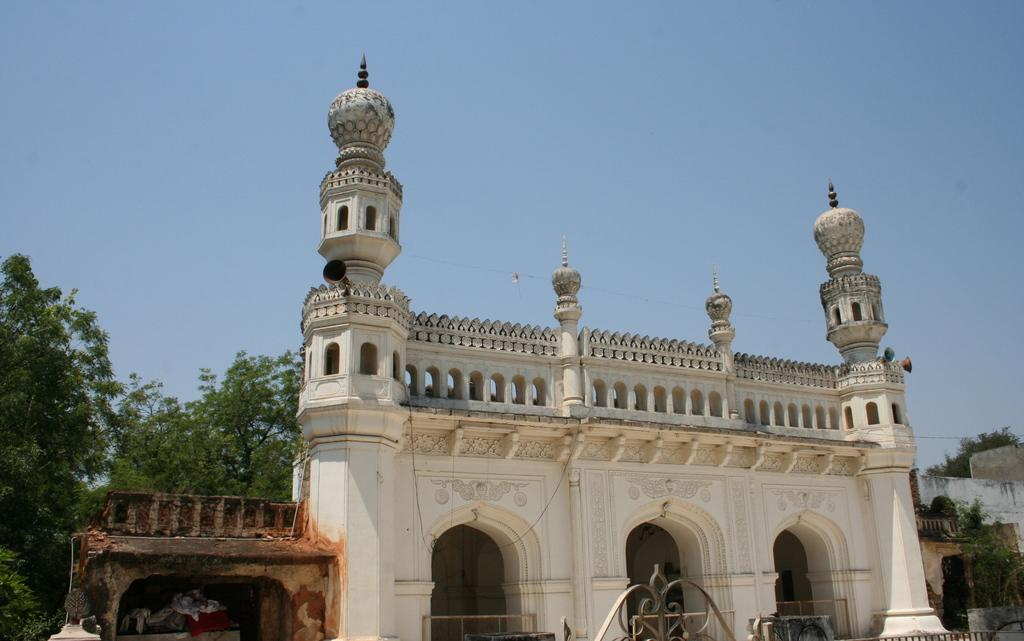What is the main subject of the image? There is a monument in the image. What can be seen in the background of the image? There are trees and the sky visible in the background of the image. What is the chance of finding a cork in the monument? There is no mention of a cork in the image, and it is not a part of the monument. 